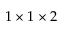Convert formula to latex. <formula><loc_0><loc_0><loc_500><loc_500>1 \times 1 \times 2</formula> 